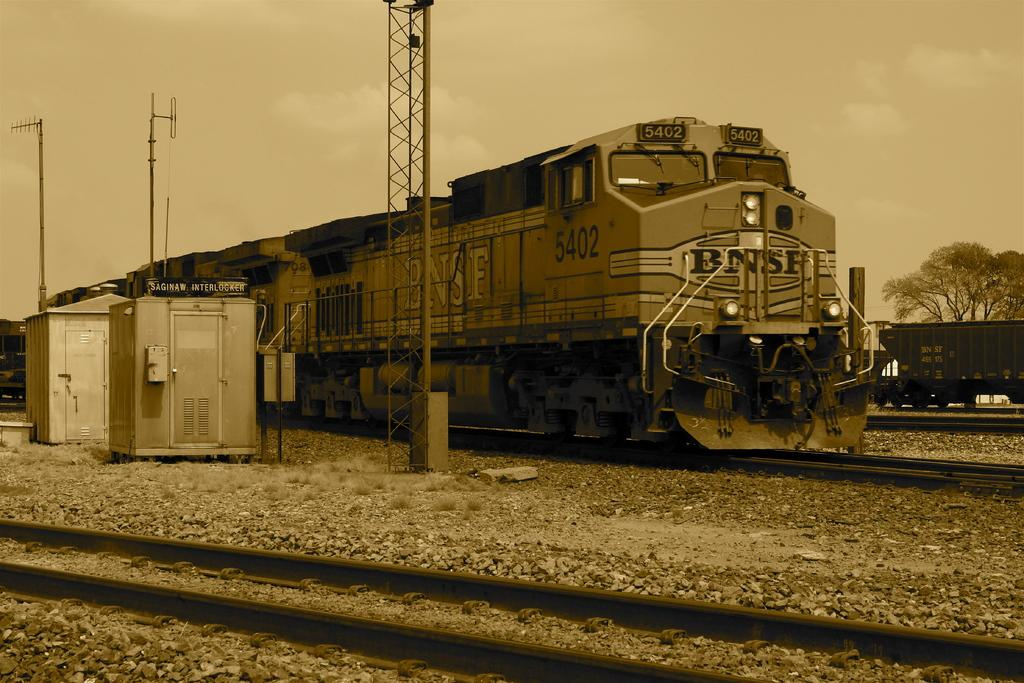How many trains can be seen in the image? There are 2 trains in the image. Are the trains on the same railway track? No, the trains are on different railway tracks. What can be seen on the left side of the image? There are poles and machines visible on the left side of the image. How many gloves are being used by the trains in the image? There are no gloves present in the image, as trains do not use gloves. Can you tell me how many times the trains sneeze in the image? Trains do not sneeze, so this action cannot be observed in the image. 